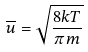<formula> <loc_0><loc_0><loc_500><loc_500>\overline { u } = \sqrt { \frac { 8 k T } { \pi m } }</formula> 